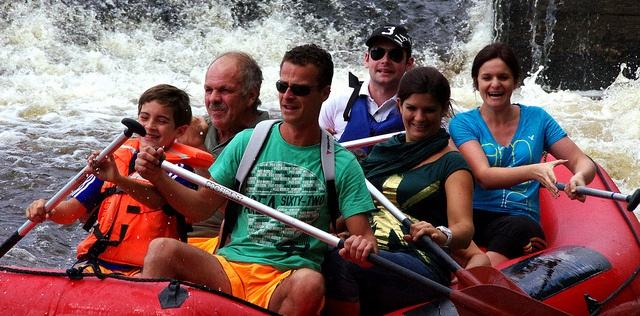Describe the objects in this image and their specific colors. I can see people in darkgray, black, maroon, teal, and brown tones, boat in darkgray, salmon, black, and brown tones, people in darkgray, black, brown, maroon, and blue tones, people in darkgray, black, brown, and maroon tones, and people in darkgray, black, maroon, and red tones in this image. 